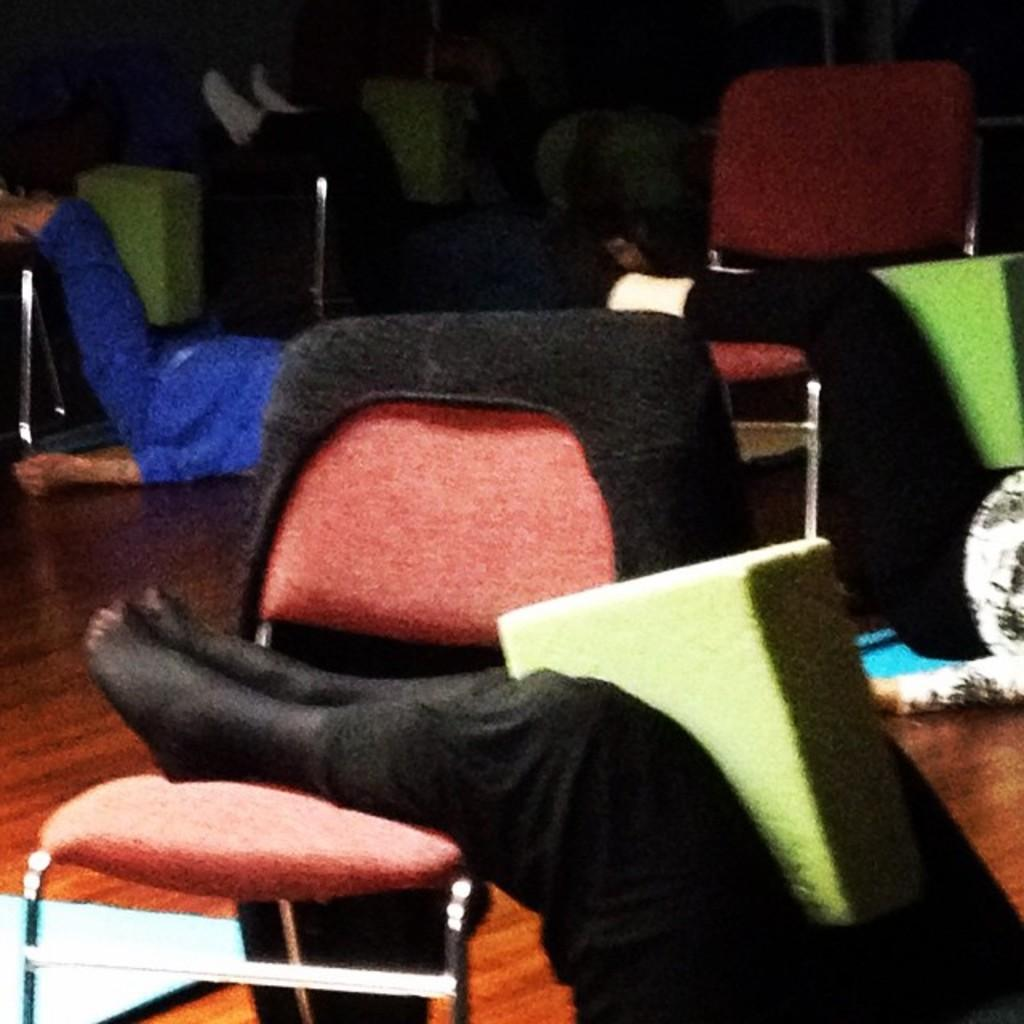What are the people in the image doing? The people in the image are lying on the floor with their legs on chairs. What is on the floor in the image? There is an object on the floor in the image. What are the people holding with their legs? There are objects held by people's legs in the image. How does the friction between the seashore and the minute particles affect the image? There is no reference to a seashore or minute particles in the image, so it is not possible to determine how friction might affect the image. 